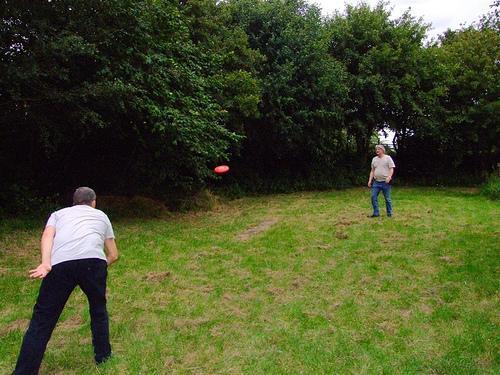How many people are in the photo?
Give a very brief answer. 2. How many people are playing with the red frisbee?
Give a very brief answer. 2. 